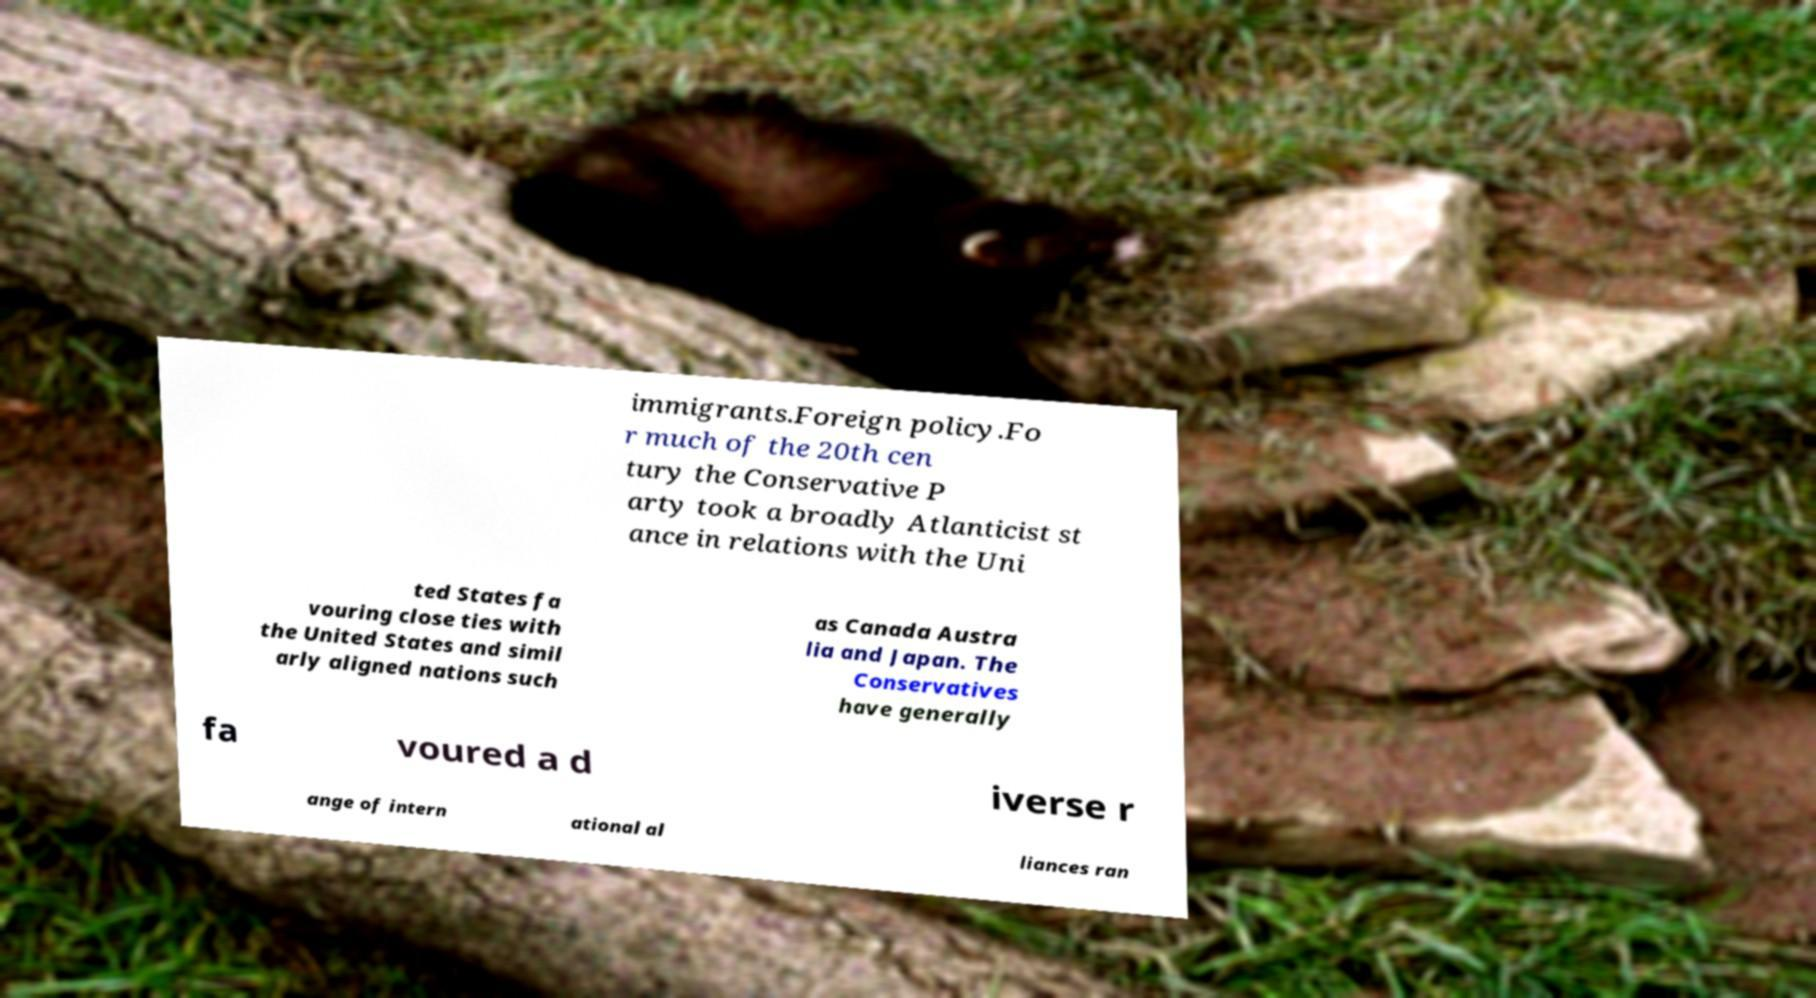What messages or text are displayed in this image? I need them in a readable, typed format. immigrants.Foreign policy.Fo r much of the 20th cen tury the Conservative P arty took a broadly Atlanticist st ance in relations with the Uni ted States fa vouring close ties with the United States and simil arly aligned nations such as Canada Austra lia and Japan. The Conservatives have generally fa voured a d iverse r ange of intern ational al liances ran 